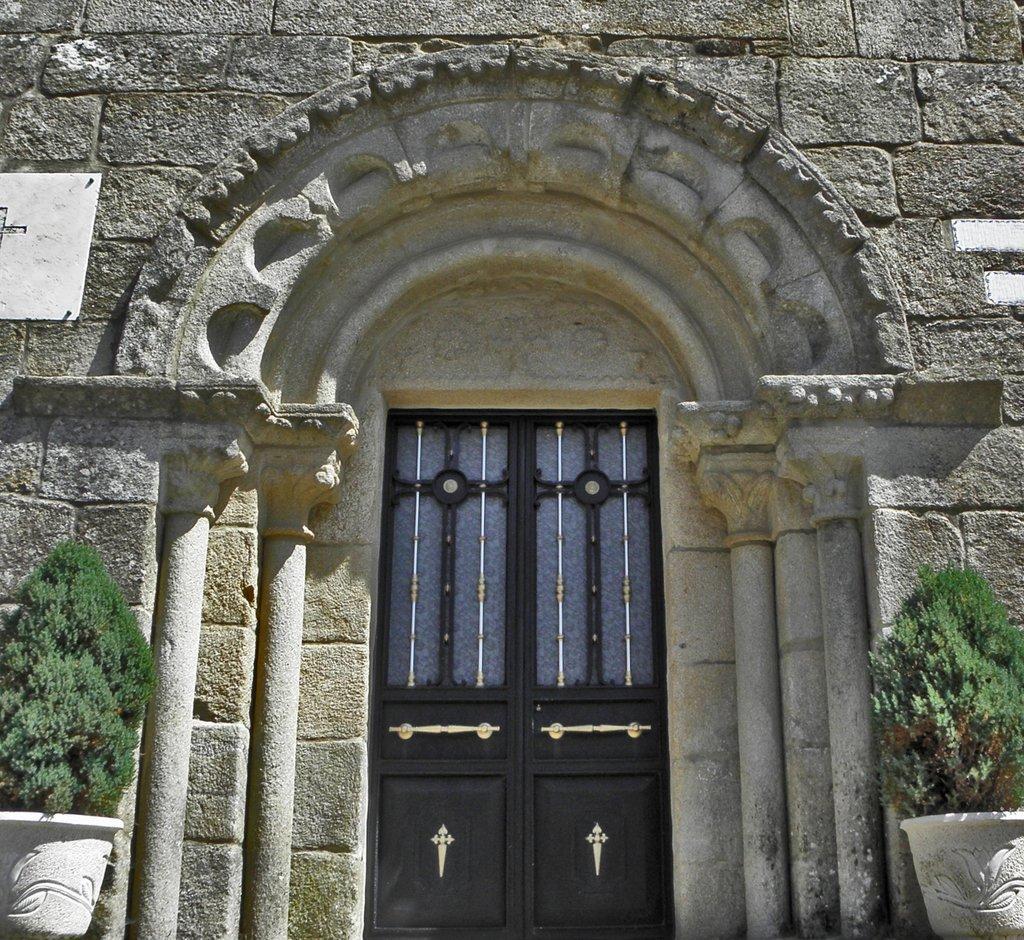Can you describe this image briefly? In this image we can see the wooden door, stone wall and flower pots on the either side of the image. 